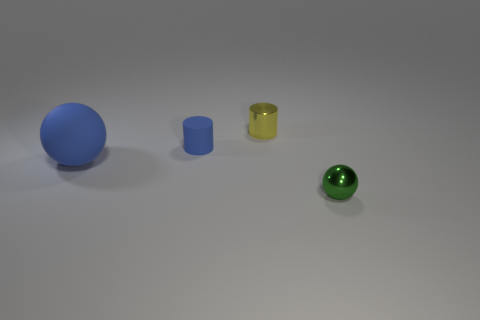Is the sphere that is on the right side of the yellow metallic object made of the same material as the large blue ball?
Ensure brevity in your answer.  No. Do the tiny rubber thing and the small green metallic thing have the same shape?
Your answer should be very brief. No. What number of objects are either small things that are left of the metal ball or tiny yellow cylinders?
Provide a short and direct response. 2. The other blue object that is the same material as the big thing is what size?
Offer a terse response. Small. What number of big spheres are the same color as the large rubber thing?
Give a very brief answer. 0. What number of large things are red matte things or blue matte cylinders?
Provide a succinct answer. 0. The other object that is the same color as the tiny matte object is what size?
Offer a terse response. Large. Are there any purple spheres made of the same material as the tiny blue thing?
Keep it short and to the point. No. There is a small thing that is in front of the tiny blue matte object; what is its material?
Ensure brevity in your answer.  Metal. There is a shiny thing right of the tiny yellow cylinder; is it the same color as the tiny metal thing that is to the left of the metal sphere?
Give a very brief answer. No. 